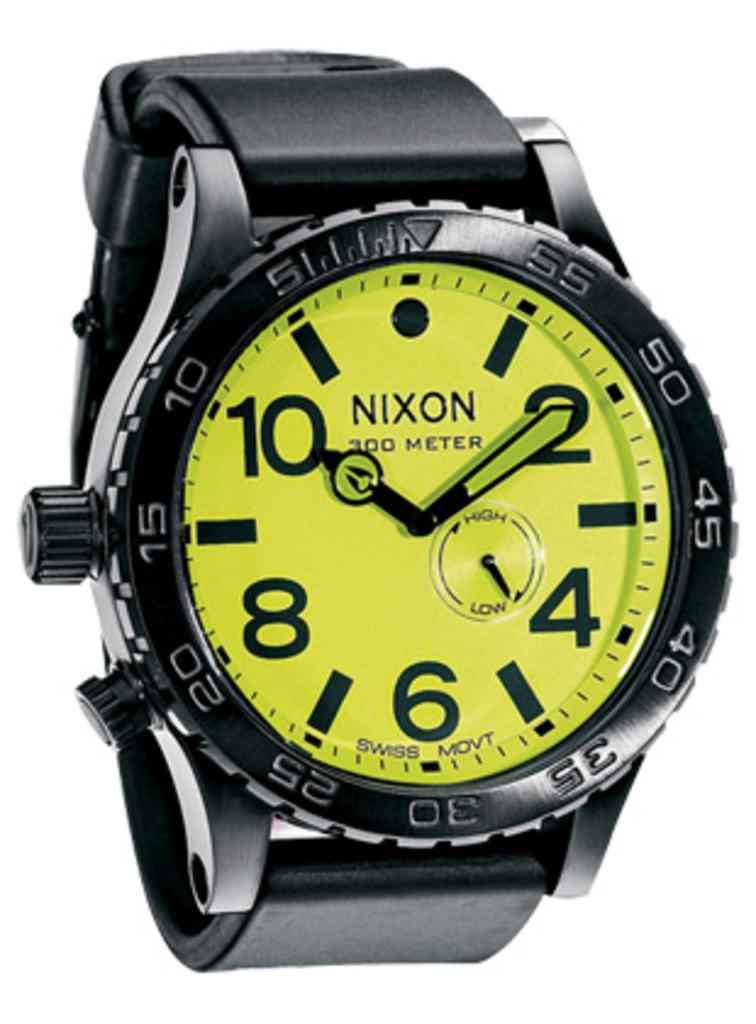Provide a one-sentence caption for the provided image. Nixon is the brand of the hand watch. 